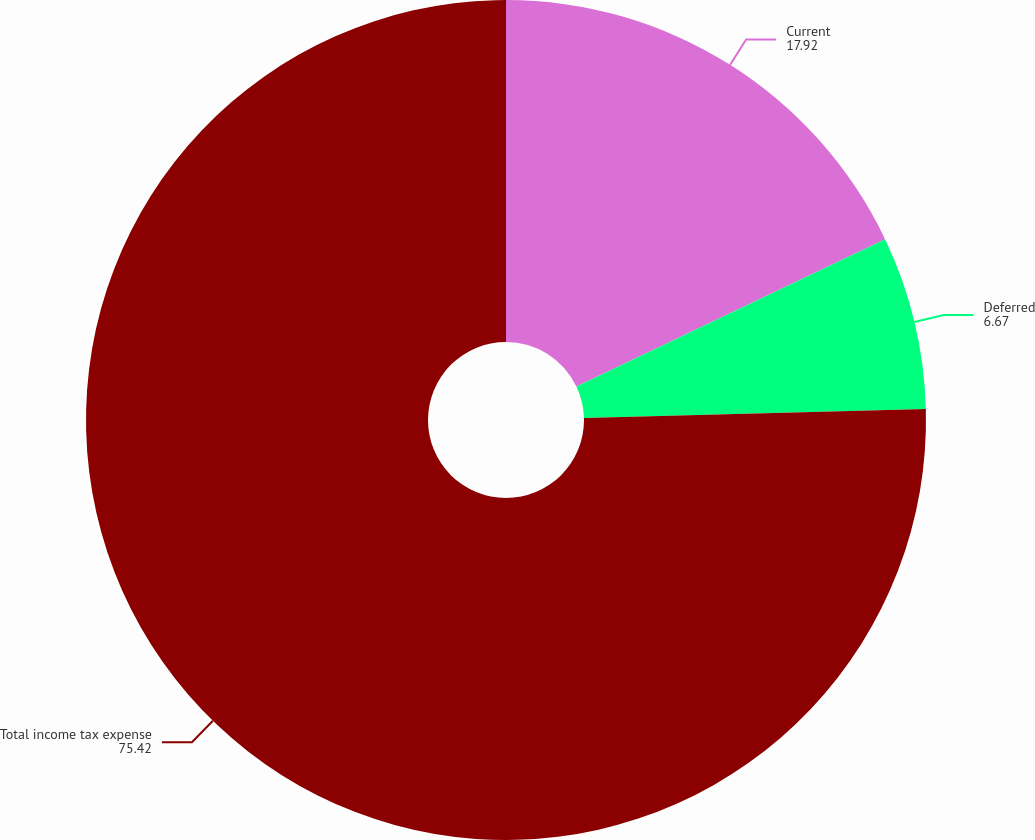Convert chart to OTSL. <chart><loc_0><loc_0><loc_500><loc_500><pie_chart><fcel>Current<fcel>Deferred<fcel>Total income tax expense<nl><fcel>17.92%<fcel>6.67%<fcel>75.42%<nl></chart> 